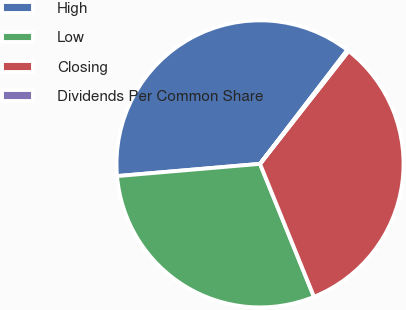Convert chart. <chart><loc_0><loc_0><loc_500><loc_500><pie_chart><fcel>High<fcel>Low<fcel>Closing<fcel>Dividends Per Common Share<nl><fcel>36.77%<fcel>29.78%<fcel>33.27%<fcel>0.18%<nl></chart> 